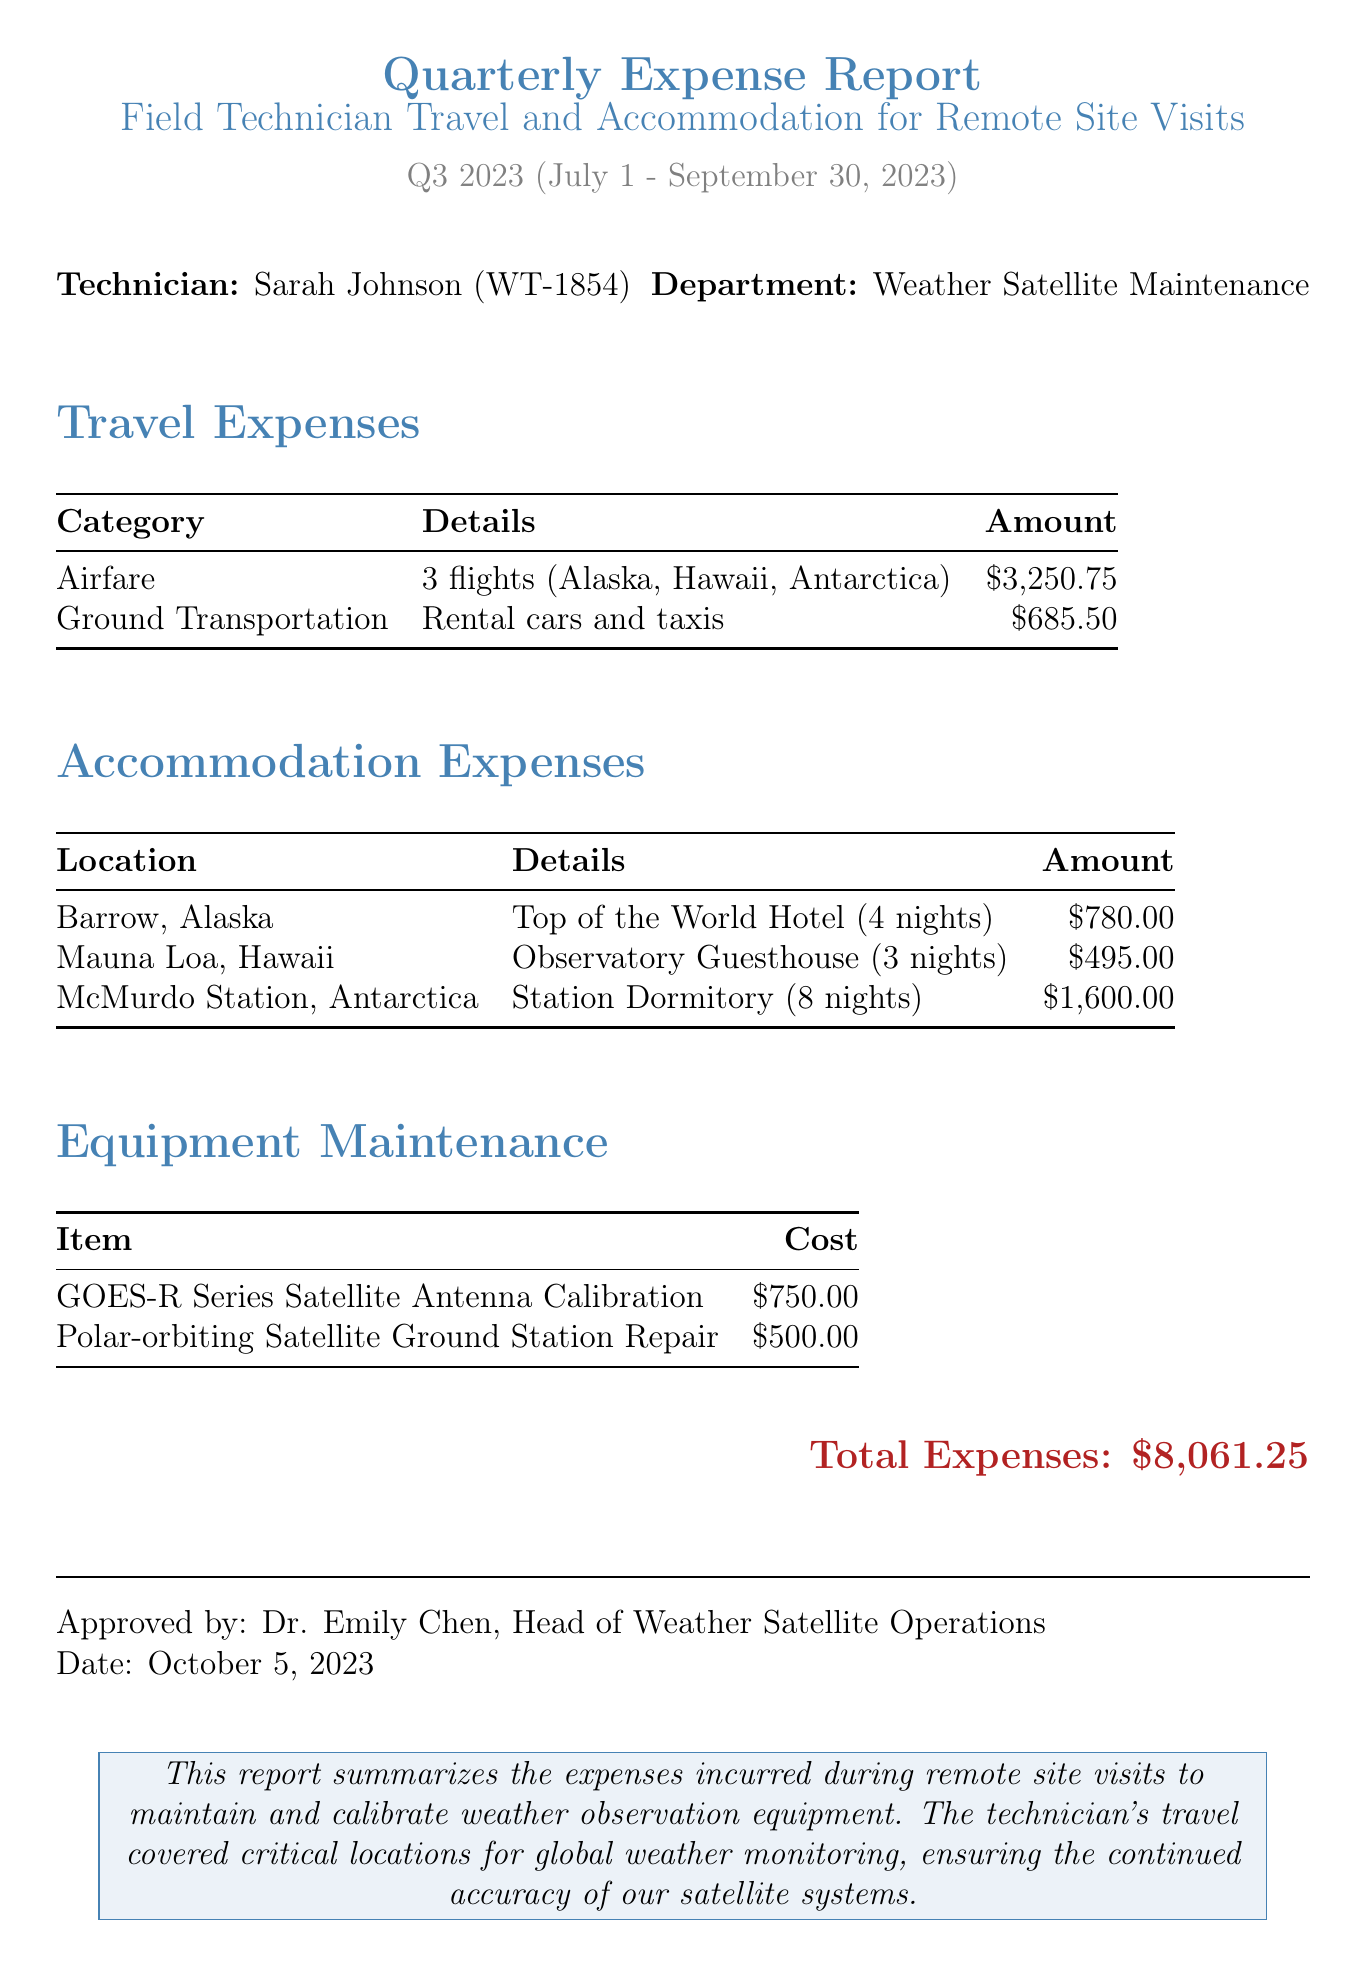What is the report title? The title of the report is stated clearly in the document at the beginning.
Answer: Quarterly Expense Report: Field Technician Travel and Accommodation for Remote Site Visits Who is the technician? The document specifies the name and employee ID of the technician.
Answer: Sarah Johnson What is the total airfare expense? The total airfare is clearly listed under the travel expenses section of the report.
Answer: 3250.75 How much was spent on accommodation at McMurdo Station? The cost for accommodation at McMurdo Station is detailed in the accommodation expenses section.
Answer: 1600.00 What category represents the highest expenses? By reviewing the total expenses in each category, one can determine where the highest costs occurred.
Answer: Travel Expenses Who approved the report? The name of the person who approved the report is mentioned towards the end of the document.
Answer: Dr. Emily Chen What was the total expense for equipment maintenance? The total cost for equipment maintenance items is summarized in the equipment maintenance section.
Answer: 1250.00 What date does the report cover? The reporting period is specified at the beginning of the document, indicating when the expenses were incurred.
Answer: Q3 2023 (July 1 - September 30, 2023) What type of transportation did the technician use in Barrow, Alaska? The document lists the types of ground transportation expenses incurred in specific locations.
Answer: Rental Car 